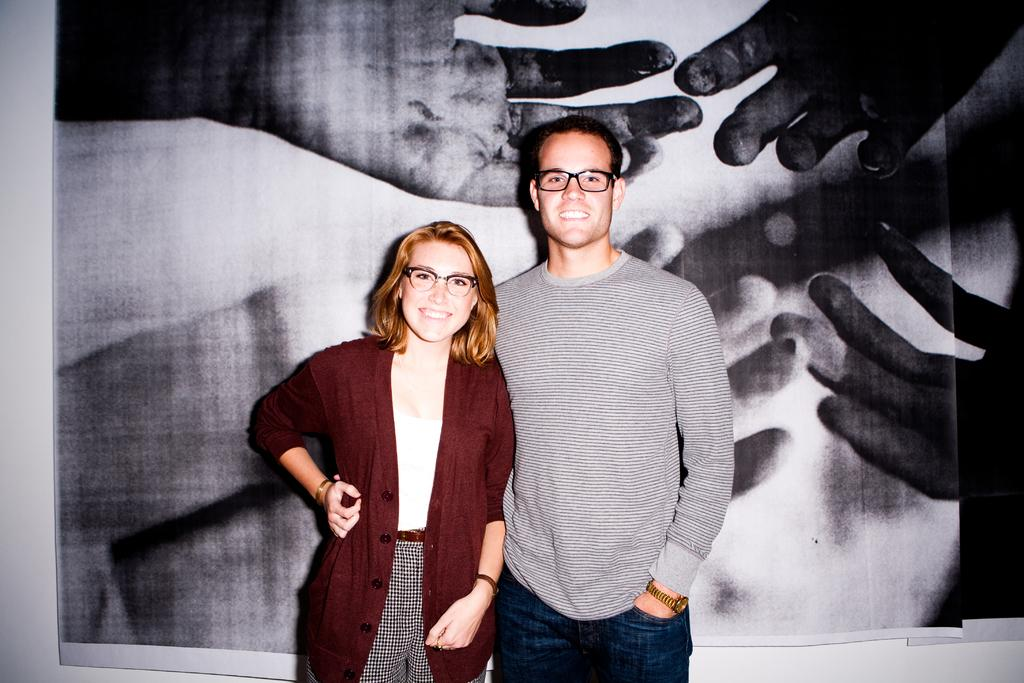How many people are present in the image? There are two people in the image, a woman and a man. What are the people in the image doing? Both the woman and the man are standing and smiling. What can be seen in the background of the image? There is a white-colored wall in the background of the image, and a huge photograph is attached to the wall. What type of paint is being used for the yard in the image? There is no yard present in the image, and therefore no paint can be observed. What is being served for dinner in the image? There is no dinner or food present in the image. 